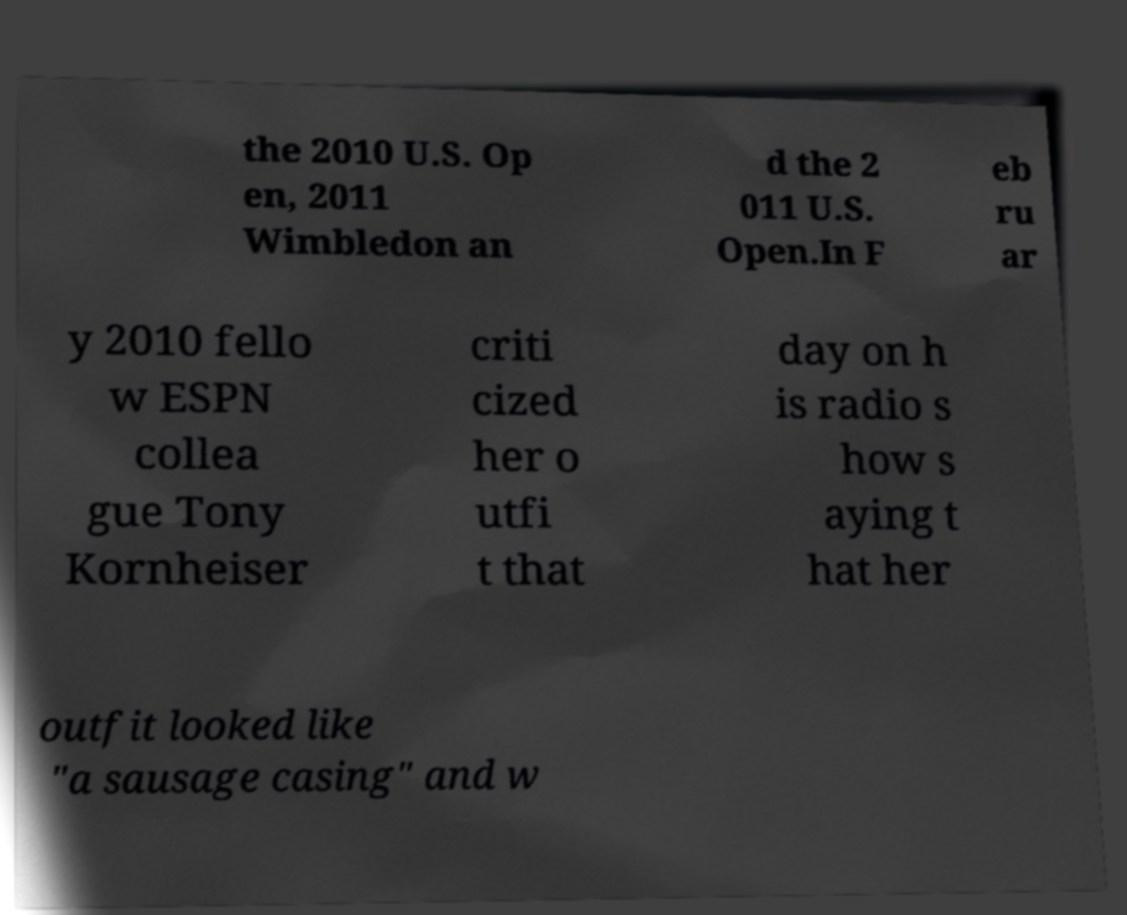What messages or text are displayed in this image? I need them in a readable, typed format. the 2010 U.S. Op en, 2011 Wimbledon an d the 2 011 U.S. Open.In F eb ru ar y 2010 fello w ESPN collea gue Tony Kornheiser criti cized her o utfi t that day on h is radio s how s aying t hat her outfit looked like "a sausage casing" and w 